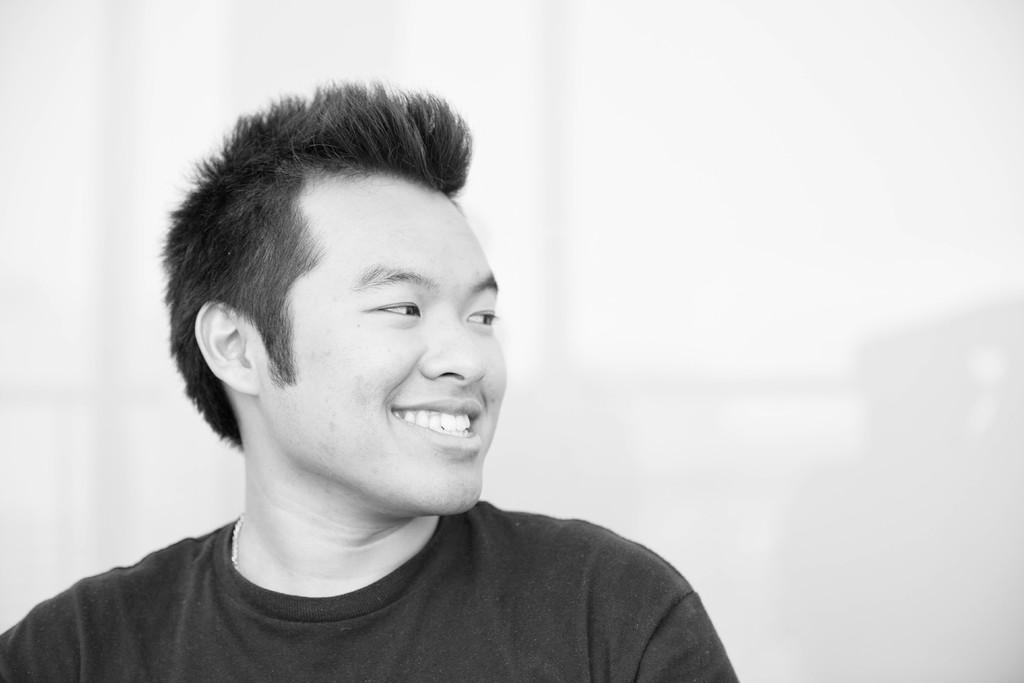What is the color scheme of the image? The image is black and white. Who is in the picture? There is a man in the picture. What is the man wearing? The man is wearing a t-shirt. What expression does the man have? The man is smiling. What color is the background of the image? The background of the image is white. Can you see the dog's tongue sticking out in the image? There is no dog present in the image, so it is not possible to see its tongue. 